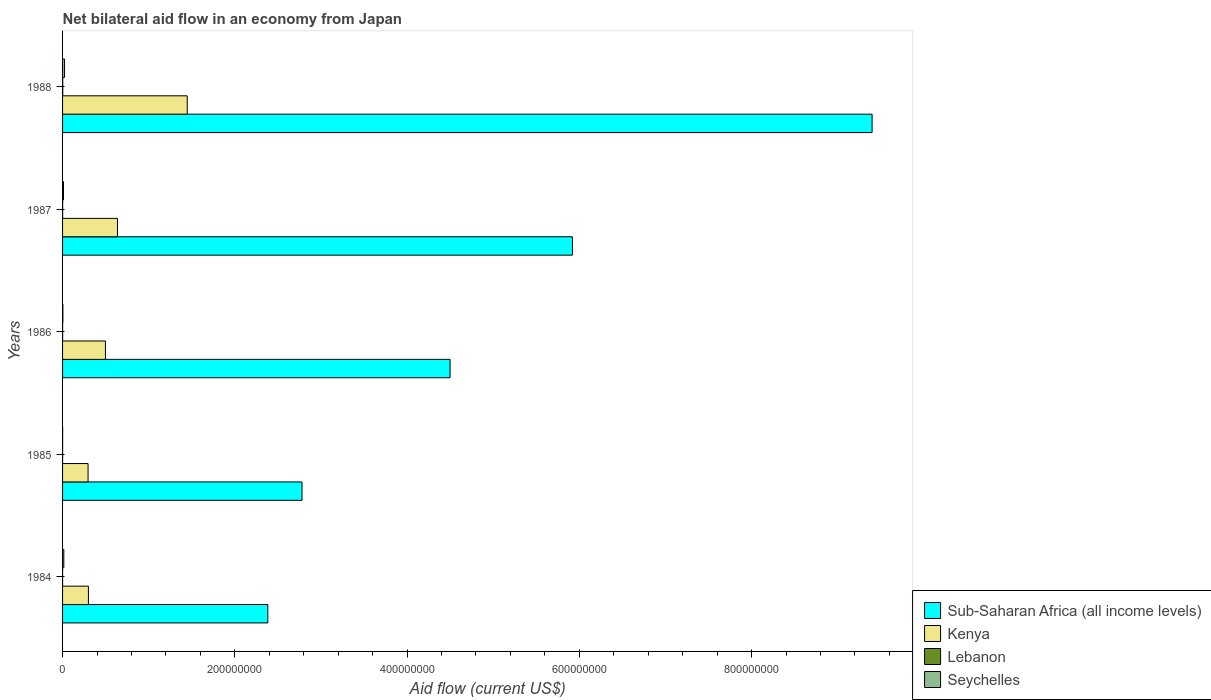How many different coloured bars are there?
Keep it short and to the point. 4. Are the number of bars on each tick of the Y-axis equal?
Your answer should be very brief. Yes. How many bars are there on the 5th tick from the top?
Keep it short and to the point. 4. In how many cases, is the number of bars for a given year not equal to the number of legend labels?
Ensure brevity in your answer.  0. What is the net bilateral aid flow in Lebanon in 1986?
Keep it short and to the point. 5.00e+04. Across all years, what is the maximum net bilateral aid flow in Sub-Saharan Africa (all income levels)?
Give a very brief answer. 9.40e+08. In which year was the net bilateral aid flow in Kenya maximum?
Give a very brief answer. 1988. What is the total net bilateral aid flow in Kenya in the graph?
Make the answer very short. 3.18e+08. What is the difference between the net bilateral aid flow in Kenya in 1986 and that in 1987?
Make the answer very short. -1.40e+07. What is the difference between the net bilateral aid flow in Lebanon in 1988 and the net bilateral aid flow in Seychelles in 1984?
Give a very brief answer. -1.25e+06. What is the average net bilateral aid flow in Sub-Saharan Africa (all income levels) per year?
Give a very brief answer. 5.00e+08. In the year 1985, what is the difference between the net bilateral aid flow in Sub-Saharan Africa (all income levels) and net bilateral aid flow in Seychelles?
Offer a terse response. 2.78e+08. In how many years, is the net bilateral aid flow in Seychelles greater than 120000000 US$?
Your answer should be very brief. 0. What is the ratio of the net bilateral aid flow in Sub-Saharan Africa (all income levels) in 1984 to that in 1986?
Your answer should be compact. 0.53. Is the net bilateral aid flow in Kenya in 1984 less than that in 1986?
Make the answer very short. Yes. Is the difference between the net bilateral aid flow in Sub-Saharan Africa (all income levels) in 1984 and 1987 greater than the difference between the net bilateral aid flow in Seychelles in 1984 and 1987?
Give a very brief answer. No. What is the difference between the highest and the second highest net bilateral aid flow in Seychelles?
Give a very brief answer. 8.60e+05. What is the difference between the highest and the lowest net bilateral aid flow in Sub-Saharan Africa (all income levels)?
Your response must be concise. 7.02e+08. What does the 4th bar from the top in 1987 represents?
Offer a very short reply. Sub-Saharan Africa (all income levels). What does the 3rd bar from the bottom in 1986 represents?
Make the answer very short. Lebanon. How many bars are there?
Make the answer very short. 20. What is the difference between two consecutive major ticks on the X-axis?
Your response must be concise. 2.00e+08. Are the values on the major ticks of X-axis written in scientific E-notation?
Your response must be concise. No. Where does the legend appear in the graph?
Ensure brevity in your answer.  Bottom right. What is the title of the graph?
Your answer should be very brief. Net bilateral aid flow in an economy from Japan. What is the label or title of the X-axis?
Offer a terse response. Aid flow (current US$). What is the label or title of the Y-axis?
Give a very brief answer. Years. What is the Aid flow (current US$) in Sub-Saharan Africa (all income levels) in 1984?
Your answer should be very brief. 2.38e+08. What is the Aid flow (current US$) of Kenya in 1984?
Keep it short and to the point. 3.00e+07. What is the Aid flow (current US$) in Seychelles in 1984?
Ensure brevity in your answer.  1.44e+06. What is the Aid flow (current US$) in Sub-Saharan Africa (all income levels) in 1985?
Keep it short and to the point. 2.78e+08. What is the Aid flow (current US$) of Kenya in 1985?
Offer a very short reply. 2.96e+07. What is the Aid flow (current US$) in Seychelles in 1985?
Your answer should be very brief. 7.00e+04. What is the Aid flow (current US$) in Sub-Saharan Africa (all income levels) in 1986?
Offer a terse response. 4.50e+08. What is the Aid flow (current US$) of Kenya in 1986?
Offer a very short reply. 4.98e+07. What is the Aid flow (current US$) in Lebanon in 1986?
Offer a very short reply. 5.00e+04. What is the Aid flow (current US$) in Seychelles in 1986?
Your answer should be compact. 3.60e+05. What is the Aid flow (current US$) in Sub-Saharan Africa (all income levels) in 1987?
Give a very brief answer. 5.92e+08. What is the Aid flow (current US$) of Kenya in 1987?
Provide a short and direct response. 6.37e+07. What is the Aid flow (current US$) in Lebanon in 1987?
Give a very brief answer. 8.00e+04. What is the Aid flow (current US$) in Seychelles in 1987?
Provide a succinct answer. 1.09e+06. What is the Aid flow (current US$) of Sub-Saharan Africa (all income levels) in 1988?
Offer a very short reply. 9.40e+08. What is the Aid flow (current US$) of Kenya in 1988?
Your answer should be very brief. 1.45e+08. What is the Aid flow (current US$) in Seychelles in 1988?
Your answer should be very brief. 2.30e+06. Across all years, what is the maximum Aid flow (current US$) of Sub-Saharan Africa (all income levels)?
Your answer should be compact. 9.40e+08. Across all years, what is the maximum Aid flow (current US$) in Kenya?
Your answer should be compact. 1.45e+08. Across all years, what is the maximum Aid flow (current US$) of Lebanon?
Provide a short and direct response. 1.90e+05. Across all years, what is the maximum Aid flow (current US$) of Seychelles?
Your answer should be very brief. 2.30e+06. Across all years, what is the minimum Aid flow (current US$) in Sub-Saharan Africa (all income levels)?
Make the answer very short. 2.38e+08. Across all years, what is the minimum Aid flow (current US$) of Kenya?
Your response must be concise. 2.96e+07. Across all years, what is the minimum Aid flow (current US$) of Seychelles?
Make the answer very short. 7.00e+04. What is the total Aid flow (current US$) in Sub-Saharan Africa (all income levels) in the graph?
Your response must be concise. 2.50e+09. What is the total Aid flow (current US$) of Kenya in the graph?
Keep it short and to the point. 3.18e+08. What is the total Aid flow (current US$) in Seychelles in the graph?
Your answer should be compact. 5.26e+06. What is the difference between the Aid flow (current US$) of Sub-Saharan Africa (all income levels) in 1984 and that in 1985?
Provide a succinct answer. -3.97e+07. What is the difference between the Aid flow (current US$) of Kenya in 1984 and that in 1985?
Provide a short and direct response. 4.10e+05. What is the difference between the Aid flow (current US$) in Seychelles in 1984 and that in 1985?
Make the answer very short. 1.37e+06. What is the difference between the Aid flow (current US$) of Sub-Saharan Africa (all income levels) in 1984 and that in 1986?
Give a very brief answer. -2.12e+08. What is the difference between the Aid flow (current US$) of Kenya in 1984 and that in 1986?
Your answer should be compact. -1.98e+07. What is the difference between the Aid flow (current US$) of Seychelles in 1984 and that in 1986?
Your answer should be very brief. 1.08e+06. What is the difference between the Aid flow (current US$) of Sub-Saharan Africa (all income levels) in 1984 and that in 1987?
Offer a terse response. -3.54e+08. What is the difference between the Aid flow (current US$) of Kenya in 1984 and that in 1987?
Offer a very short reply. -3.37e+07. What is the difference between the Aid flow (current US$) of Seychelles in 1984 and that in 1987?
Keep it short and to the point. 3.50e+05. What is the difference between the Aid flow (current US$) in Sub-Saharan Africa (all income levels) in 1984 and that in 1988?
Your response must be concise. -7.02e+08. What is the difference between the Aid flow (current US$) in Kenya in 1984 and that in 1988?
Your response must be concise. -1.15e+08. What is the difference between the Aid flow (current US$) in Seychelles in 1984 and that in 1988?
Ensure brevity in your answer.  -8.60e+05. What is the difference between the Aid flow (current US$) of Sub-Saharan Africa (all income levels) in 1985 and that in 1986?
Keep it short and to the point. -1.72e+08. What is the difference between the Aid flow (current US$) in Kenya in 1985 and that in 1986?
Offer a very short reply. -2.02e+07. What is the difference between the Aid flow (current US$) of Sub-Saharan Africa (all income levels) in 1985 and that in 1987?
Your answer should be compact. -3.14e+08. What is the difference between the Aid flow (current US$) in Kenya in 1985 and that in 1987?
Your answer should be compact. -3.41e+07. What is the difference between the Aid flow (current US$) of Lebanon in 1985 and that in 1987?
Provide a short and direct response. -4.00e+04. What is the difference between the Aid flow (current US$) in Seychelles in 1985 and that in 1987?
Offer a very short reply. -1.02e+06. What is the difference between the Aid flow (current US$) in Sub-Saharan Africa (all income levels) in 1985 and that in 1988?
Provide a short and direct response. -6.62e+08. What is the difference between the Aid flow (current US$) of Kenya in 1985 and that in 1988?
Your answer should be very brief. -1.15e+08. What is the difference between the Aid flow (current US$) in Lebanon in 1985 and that in 1988?
Provide a succinct answer. -1.50e+05. What is the difference between the Aid flow (current US$) in Seychelles in 1985 and that in 1988?
Provide a succinct answer. -2.23e+06. What is the difference between the Aid flow (current US$) in Sub-Saharan Africa (all income levels) in 1986 and that in 1987?
Provide a succinct answer. -1.42e+08. What is the difference between the Aid flow (current US$) in Kenya in 1986 and that in 1987?
Offer a very short reply. -1.40e+07. What is the difference between the Aid flow (current US$) in Seychelles in 1986 and that in 1987?
Offer a very short reply. -7.30e+05. What is the difference between the Aid flow (current US$) in Sub-Saharan Africa (all income levels) in 1986 and that in 1988?
Your answer should be very brief. -4.90e+08. What is the difference between the Aid flow (current US$) of Kenya in 1986 and that in 1988?
Provide a succinct answer. -9.50e+07. What is the difference between the Aid flow (current US$) of Seychelles in 1986 and that in 1988?
Offer a terse response. -1.94e+06. What is the difference between the Aid flow (current US$) of Sub-Saharan Africa (all income levels) in 1987 and that in 1988?
Your answer should be very brief. -3.48e+08. What is the difference between the Aid flow (current US$) in Kenya in 1987 and that in 1988?
Keep it short and to the point. -8.10e+07. What is the difference between the Aid flow (current US$) of Lebanon in 1987 and that in 1988?
Offer a very short reply. -1.10e+05. What is the difference between the Aid flow (current US$) of Seychelles in 1987 and that in 1988?
Provide a succinct answer. -1.21e+06. What is the difference between the Aid flow (current US$) in Sub-Saharan Africa (all income levels) in 1984 and the Aid flow (current US$) in Kenya in 1985?
Provide a short and direct response. 2.09e+08. What is the difference between the Aid flow (current US$) of Sub-Saharan Africa (all income levels) in 1984 and the Aid flow (current US$) of Lebanon in 1985?
Give a very brief answer. 2.38e+08. What is the difference between the Aid flow (current US$) in Sub-Saharan Africa (all income levels) in 1984 and the Aid flow (current US$) in Seychelles in 1985?
Keep it short and to the point. 2.38e+08. What is the difference between the Aid flow (current US$) of Kenya in 1984 and the Aid flow (current US$) of Lebanon in 1985?
Offer a terse response. 3.00e+07. What is the difference between the Aid flow (current US$) in Kenya in 1984 and the Aid flow (current US$) in Seychelles in 1985?
Offer a very short reply. 3.00e+07. What is the difference between the Aid flow (current US$) of Sub-Saharan Africa (all income levels) in 1984 and the Aid flow (current US$) of Kenya in 1986?
Make the answer very short. 1.89e+08. What is the difference between the Aid flow (current US$) of Sub-Saharan Africa (all income levels) in 1984 and the Aid flow (current US$) of Lebanon in 1986?
Offer a very short reply. 2.38e+08. What is the difference between the Aid flow (current US$) in Sub-Saharan Africa (all income levels) in 1984 and the Aid flow (current US$) in Seychelles in 1986?
Provide a succinct answer. 2.38e+08. What is the difference between the Aid flow (current US$) of Kenya in 1984 and the Aid flow (current US$) of Lebanon in 1986?
Provide a succinct answer. 3.00e+07. What is the difference between the Aid flow (current US$) in Kenya in 1984 and the Aid flow (current US$) in Seychelles in 1986?
Ensure brevity in your answer.  2.97e+07. What is the difference between the Aid flow (current US$) of Sub-Saharan Africa (all income levels) in 1984 and the Aid flow (current US$) of Kenya in 1987?
Provide a succinct answer. 1.75e+08. What is the difference between the Aid flow (current US$) in Sub-Saharan Africa (all income levels) in 1984 and the Aid flow (current US$) in Lebanon in 1987?
Give a very brief answer. 2.38e+08. What is the difference between the Aid flow (current US$) in Sub-Saharan Africa (all income levels) in 1984 and the Aid flow (current US$) in Seychelles in 1987?
Provide a short and direct response. 2.37e+08. What is the difference between the Aid flow (current US$) of Kenya in 1984 and the Aid flow (current US$) of Lebanon in 1987?
Make the answer very short. 2.99e+07. What is the difference between the Aid flow (current US$) in Kenya in 1984 and the Aid flow (current US$) in Seychelles in 1987?
Keep it short and to the point. 2.89e+07. What is the difference between the Aid flow (current US$) of Lebanon in 1984 and the Aid flow (current US$) of Seychelles in 1987?
Provide a short and direct response. -1.07e+06. What is the difference between the Aid flow (current US$) in Sub-Saharan Africa (all income levels) in 1984 and the Aid flow (current US$) in Kenya in 1988?
Provide a succinct answer. 9.36e+07. What is the difference between the Aid flow (current US$) of Sub-Saharan Africa (all income levels) in 1984 and the Aid flow (current US$) of Lebanon in 1988?
Make the answer very short. 2.38e+08. What is the difference between the Aid flow (current US$) in Sub-Saharan Africa (all income levels) in 1984 and the Aid flow (current US$) in Seychelles in 1988?
Provide a succinct answer. 2.36e+08. What is the difference between the Aid flow (current US$) in Kenya in 1984 and the Aid flow (current US$) in Lebanon in 1988?
Your response must be concise. 2.98e+07. What is the difference between the Aid flow (current US$) of Kenya in 1984 and the Aid flow (current US$) of Seychelles in 1988?
Offer a very short reply. 2.77e+07. What is the difference between the Aid flow (current US$) of Lebanon in 1984 and the Aid flow (current US$) of Seychelles in 1988?
Give a very brief answer. -2.28e+06. What is the difference between the Aid flow (current US$) of Sub-Saharan Africa (all income levels) in 1985 and the Aid flow (current US$) of Kenya in 1986?
Provide a short and direct response. 2.28e+08. What is the difference between the Aid flow (current US$) of Sub-Saharan Africa (all income levels) in 1985 and the Aid flow (current US$) of Lebanon in 1986?
Your answer should be compact. 2.78e+08. What is the difference between the Aid flow (current US$) of Sub-Saharan Africa (all income levels) in 1985 and the Aid flow (current US$) of Seychelles in 1986?
Your answer should be very brief. 2.78e+08. What is the difference between the Aid flow (current US$) in Kenya in 1985 and the Aid flow (current US$) in Lebanon in 1986?
Keep it short and to the point. 2.96e+07. What is the difference between the Aid flow (current US$) of Kenya in 1985 and the Aid flow (current US$) of Seychelles in 1986?
Offer a terse response. 2.92e+07. What is the difference between the Aid flow (current US$) in Lebanon in 1985 and the Aid flow (current US$) in Seychelles in 1986?
Offer a very short reply. -3.20e+05. What is the difference between the Aid flow (current US$) in Sub-Saharan Africa (all income levels) in 1985 and the Aid flow (current US$) in Kenya in 1987?
Make the answer very short. 2.14e+08. What is the difference between the Aid flow (current US$) of Sub-Saharan Africa (all income levels) in 1985 and the Aid flow (current US$) of Lebanon in 1987?
Keep it short and to the point. 2.78e+08. What is the difference between the Aid flow (current US$) of Sub-Saharan Africa (all income levels) in 1985 and the Aid flow (current US$) of Seychelles in 1987?
Make the answer very short. 2.77e+08. What is the difference between the Aid flow (current US$) of Kenya in 1985 and the Aid flow (current US$) of Lebanon in 1987?
Ensure brevity in your answer.  2.95e+07. What is the difference between the Aid flow (current US$) in Kenya in 1985 and the Aid flow (current US$) in Seychelles in 1987?
Provide a succinct answer. 2.85e+07. What is the difference between the Aid flow (current US$) of Lebanon in 1985 and the Aid flow (current US$) of Seychelles in 1987?
Provide a short and direct response. -1.05e+06. What is the difference between the Aid flow (current US$) in Sub-Saharan Africa (all income levels) in 1985 and the Aid flow (current US$) in Kenya in 1988?
Make the answer very short. 1.33e+08. What is the difference between the Aid flow (current US$) in Sub-Saharan Africa (all income levels) in 1985 and the Aid flow (current US$) in Lebanon in 1988?
Your answer should be compact. 2.78e+08. What is the difference between the Aid flow (current US$) of Sub-Saharan Africa (all income levels) in 1985 and the Aid flow (current US$) of Seychelles in 1988?
Give a very brief answer. 2.76e+08. What is the difference between the Aid flow (current US$) in Kenya in 1985 and the Aid flow (current US$) in Lebanon in 1988?
Offer a very short reply. 2.94e+07. What is the difference between the Aid flow (current US$) in Kenya in 1985 and the Aid flow (current US$) in Seychelles in 1988?
Offer a terse response. 2.73e+07. What is the difference between the Aid flow (current US$) of Lebanon in 1985 and the Aid flow (current US$) of Seychelles in 1988?
Keep it short and to the point. -2.26e+06. What is the difference between the Aid flow (current US$) of Sub-Saharan Africa (all income levels) in 1986 and the Aid flow (current US$) of Kenya in 1987?
Offer a very short reply. 3.86e+08. What is the difference between the Aid flow (current US$) in Sub-Saharan Africa (all income levels) in 1986 and the Aid flow (current US$) in Lebanon in 1987?
Keep it short and to the point. 4.50e+08. What is the difference between the Aid flow (current US$) in Sub-Saharan Africa (all income levels) in 1986 and the Aid flow (current US$) in Seychelles in 1987?
Ensure brevity in your answer.  4.49e+08. What is the difference between the Aid flow (current US$) of Kenya in 1986 and the Aid flow (current US$) of Lebanon in 1987?
Offer a terse response. 4.97e+07. What is the difference between the Aid flow (current US$) in Kenya in 1986 and the Aid flow (current US$) in Seychelles in 1987?
Your answer should be compact. 4.87e+07. What is the difference between the Aid flow (current US$) of Lebanon in 1986 and the Aid flow (current US$) of Seychelles in 1987?
Ensure brevity in your answer.  -1.04e+06. What is the difference between the Aid flow (current US$) in Sub-Saharan Africa (all income levels) in 1986 and the Aid flow (current US$) in Kenya in 1988?
Your response must be concise. 3.05e+08. What is the difference between the Aid flow (current US$) in Sub-Saharan Africa (all income levels) in 1986 and the Aid flow (current US$) in Lebanon in 1988?
Ensure brevity in your answer.  4.50e+08. What is the difference between the Aid flow (current US$) of Sub-Saharan Africa (all income levels) in 1986 and the Aid flow (current US$) of Seychelles in 1988?
Provide a short and direct response. 4.48e+08. What is the difference between the Aid flow (current US$) of Kenya in 1986 and the Aid flow (current US$) of Lebanon in 1988?
Give a very brief answer. 4.96e+07. What is the difference between the Aid flow (current US$) in Kenya in 1986 and the Aid flow (current US$) in Seychelles in 1988?
Your answer should be compact. 4.75e+07. What is the difference between the Aid flow (current US$) in Lebanon in 1986 and the Aid flow (current US$) in Seychelles in 1988?
Offer a terse response. -2.25e+06. What is the difference between the Aid flow (current US$) in Sub-Saharan Africa (all income levels) in 1987 and the Aid flow (current US$) in Kenya in 1988?
Give a very brief answer. 4.47e+08. What is the difference between the Aid flow (current US$) in Sub-Saharan Africa (all income levels) in 1987 and the Aid flow (current US$) in Lebanon in 1988?
Your answer should be compact. 5.92e+08. What is the difference between the Aid flow (current US$) of Sub-Saharan Africa (all income levels) in 1987 and the Aid flow (current US$) of Seychelles in 1988?
Offer a very short reply. 5.90e+08. What is the difference between the Aid flow (current US$) in Kenya in 1987 and the Aid flow (current US$) in Lebanon in 1988?
Give a very brief answer. 6.36e+07. What is the difference between the Aid flow (current US$) of Kenya in 1987 and the Aid flow (current US$) of Seychelles in 1988?
Provide a short and direct response. 6.14e+07. What is the difference between the Aid flow (current US$) in Lebanon in 1987 and the Aid flow (current US$) in Seychelles in 1988?
Offer a very short reply. -2.22e+06. What is the average Aid flow (current US$) in Sub-Saharan Africa (all income levels) per year?
Your answer should be compact. 5.00e+08. What is the average Aid flow (current US$) in Kenya per year?
Keep it short and to the point. 6.36e+07. What is the average Aid flow (current US$) in Lebanon per year?
Your response must be concise. 7.60e+04. What is the average Aid flow (current US$) in Seychelles per year?
Make the answer very short. 1.05e+06. In the year 1984, what is the difference between the Aid flow (current US$) of Sub-Saharan Africa (all income levels) and Aid flow (current US$) of Kenya?
Your answer should be very brief. 2.08e+08. In the year 1984, what is the difference between the Aid flow (current US$) in Sub-Saharan Africa (all income levels) and Aid flow (current US$) in Lebanon?
Your response must be concise. 2.38e+08. In the year 1984, what is the difference between the Aid flow (current US$) of Sub-Saharan Africa (all income levels) and Aid flow (current US$) of Seychelles?
Your response must be concise. 2.37e+08. In the year 1984, what is the difference between the Aid flow (current US$) of Kenya and Aid flow (current US$) of Lebanon?
Your answer should be very brief. 3.00e+07. In the year 1984, what is the difference between the Aid flow (current US$) in Kenya and Aid flow (current US$) in Seychelles?
Offer a very short reply. 2.86e+07. In the year 1984, what is the difference between the Aid flow (current US$) in Lebanon and Aid flow (current US$) in Seychelles?
Offer a terse response. -1.42e+06. In the year 1985, what is the difference between the Aid flow (current US$) of Sub-Saharan Africa (all income levels) and Aid flow (current US$) of Kenya?
Give a very brief answer. 2.48e+08. In the year 1985, what is the difference between the Aid flow (current US$) in Sub-Saharan Africa (all income levels) and Aid flow (current US$) in Lebanon?
Provide a short and direct response. 2.78e+08. In the year 1985, what is the difference between the Aid flow (current US$) of Sub-Saharan Africa (all income levels) and Aid flow (current US$) of Seychelles?
Offer a terse response. 2.78e+08. In the year 1985, what is the difference between the Aid flow (current US$) in Kenya and Aid flow (current US$) in Lebanon?
Ensure brevity in your answer.  2.96e+07. In the year 1985, what is the difference between the Aid flow (current US$) in Kenya and Aid flow (current US$) in Seychelles?
Your answer should be compact. 2.95e+07. In the year 1985, what is the difference between the Aid flow (current US$) in Lebanon and Aid flow (current US$) in Seychelles?
Keep it short and to the point. -3.00e+04. In the year 1986, what is the difference between the Aid flow (current US$) in Sub-Saharan Africa (all income levels) and Aid flow (current US$) in Kenya?
Give a very brief answer. 4.00e+08. In the year 1986, what is the difference between the Aid flow (current US$) of Sub-Saharan Africa (all income levels) and Aid flow (current US$) of Lebanon?
Keep it short and to the point. 4.50e+08. In the year 1986, what is the difference between the Aid flow (current US$) of Sub-Saharan Africa (all income levels) and Aid flow (current US$) of Seychelles?
Your response must be concise. 4.50e+08. In the year 1986, what is the difference between the Aid flow (current US$) in Kenya and Aid flow (current US$) in Lebanon?
Provide a succinct answer. 4.97e+07. In the year 1986, what is the difference between the Aid flow (current US$) in Kenya and Aid flow (current US$) in Seychelles?
Keep it short and to the point. 4.94e+07. In the year 1986, what is the difference between the Aid flow (current US$) in Lebanon and Aid flow (current US$) in Seychelles?
Your answer should be very brief. -3.10e+05. In the year 1987, what is the difference between the Aid flow (current US$) in Sub-Saharan Africa (all income levels) and Aid flow (current US$) in Kenya?
Your answer should be very brief. 5.28e+08. In the year 1987, what is the difference between the Aid flow (current US$) of Sub-Saharan Africa (all income levels) and Aid flow (current US$) of Lebanon?
Give a very brief answer. 5.92e+08. In the year 1987, what is the difference between the Aid flow (current US$) in Sub-Saharan Africa (all income levels) and Aid flow (current US$) in Seychelles?
Your response must be concise. 5.91e+08. In the year 1987, what is the difference between the Aid flow (current US$) of Kenya and Aid flow (current US$) of Lebanon?
Give a very brief answer. 6.37e+07. In the year 1987, what is the difference between the Aid flow (current US$) of Kenya and Aid flow (current US$) of Seychelles?
Your answer should be compact. 6.26e+07. In the year 1987, what is the difference between the Aid flow (current US$) of Lebanon and Aid flow (current US$) of Seychelles?
Give a very brief answer. -1.01e+06. In the year 1988, what is the difference between the Aid flow (current US$) in Sub-Saharan Africa (all income levels) and Aid flow (current US$) in Kenya?
Your answer should be compact. 7.95e+08. In the year 1988, what is the difference between the Aid flow (current US$) of Sub-Saharan Africa (all income levels) and Aid flow (current US$) of Lebanon?
Your answer should be very brief. 9.40e+08. In the year 1988, what is the difference between the Aid flow (current US$) of Sub-Saharan Africa (all income levels) and Aid flow (current US$) of Seychelles?
Your response must be concise. 9.38e+08. In the year 1988, what is the difference between the Aid flow (current US$) of Kenya and Aid flow (current US$) of Lebanon?
Your response must be concise. 1.45e+08. In the year 1988, what is the difference between the Aid flow (current US$) in Kenya and Aid flow (current US$) in Seychelles?
Ensure brevity in your answer.  1.42e+08. In the year 1988, what is the difference between the Aid flow (current US$) in Lebanon and Aid flow (current US$) in Seychelles?
Offer a very short reply. -2.11e+06. What is the ratio of the Aid flow (current US$) of Sub-Saharan Africa (all income levels) in 1984 to that in 1985?
Provide a short and direct response. 0.86. What is the ratio of the Aid flow (current US$) of Kenya in 1984 to that in 1985?
Keep it short and to the point. 1.01. What is the ratio of the Aid flow (current US$) of Lebanon in 1984 to that in 1985?
Provide a short and direct response. 0.5. What is the ratio of the Aid flow (current US$) of Seychelles in 1984 to that in 1985?
Provide a succinct answer. 20.57. What is the ratio of the Aid flow (current US$) in Sub-Saharan Africa (all income levels) in 1984 to that in 1986?
Keep it short and to the point. 0.53. What is the ratio of the Aid flow (current US$) of Kenya in 1984 to that in 1986?
Make the answer very short. 0.6. What is the ratio of the Aid flow (current US$) of Lebanon in 1984 to that in 1986?
Your response must be concise. 0.4. What is the ratio of the Aid flow (current US$) in Sub-Saharan Africa (all income levels) in 1984 to that in 1987?
Your answer should be very brief. 0.4. What is the ratio of the Aid flow (current US$) of Kenya in 1984 to that in 1987?
Ensure brevity in your answer.  0.47. What is the ratio of the Aid flow (current US$) of Seychelles in 1984 to that in 1987?
Your response must be concise. 1.32. What is the ratio of the Aid flow (current US$) of Sub-Saharan Africa (all income levels) in 1984 to that in 1988?
Offer a very short reply. 0.25. What is the ratio of the Aid flow (current US$) of Kenya in 1984 to that in 1988?
Your answer should be very brief. 0.21. What is the ratio of the Aid flow (current US$) of Lebanon in 1984 to that in 1988?
Your response must be concise. 0.11. What is the ratio of the Aid flow (current US$) in Seychelles in 1984 to that in 1988?
Your answer should be very brief. 0.63. What is the ratio of the Aid flow (current US$) in Sub-Saharan Africa (all income levels) in 1985 to that in 1986?
Offer a terse response. 0.62. What is the ratio of the Aid flow (current US$) of Kenya in 1985 to that in 1986?
Provide a succinct answer. 0.59. What is the ratio of the Aid flow (current US$) in Lebanon in 1985 to that in 1986?
Give a very brief answer. 0.8. What is the ratio of the Aid flow (current US$) of Seychelles in 1985 to that in 1986?
Offer a terse response. 0.19. What is the ratio of the Aid flow (current US$) of Sub-Saharan Africa (all income levels) in 1985 to that in 1987?
Ensure brevity in your answer.  0.47. What is the ratio of the Aid flow (current US$) of Kenya in 1985 to that in 1987?
Offer a very short reply. 0.46. What is the ratio of the Aid flow (current US$) in Seychelles in 1985 to that in 1987?
Offer a terse response. 0.06. What is the ratio of the Aid flow (current US$) of Sub-Saharan Africa (all income levels) in 1985 to that in 1988?
Your answer should be compact. 0.3. What is the ratio of the Aid flow (current US$) in Kenya in 1985 to that in 1988?
Offer a very short reply. 0.2. What is the ratio of the Aid flow (current US$) of Lebanon in 1985 to that in 1988?
Make the answer very short. 0.21. What is the ratio of the Aid flow (current US$) of Seychelles in 1985 to that in 1988?
Offer a very short reply. 0.03. What is the ratio of the Aid flow (current US$) in Sub-Saharan Africa (all income levels) in 1986 to that in 1987?
Give a very brief answer. 0.76. What is the ratio of the Aid flow (current US$) of Kenya in 1986 to that in 1987?
Offer a very short reply. 0.78. What is the ratio of the Aid flow (current US$) of Lebanon in 1986 to that in 1987?
Your answer should be compact. 0.62. What is the ratio of the Aid flow (current US$) in Seychelles in 1986 to that in 1987?
Make the answer very short. 0.33. What is the ratio of the Aid flow (current US$) in Sub-Saharan Africa (all income levels) in 1986 to that in 1988?
Offer a very short reply. 0.48. What is the ratio of the Aid flow (current US$) of Kenya in 1986 to that in 1988?
Offer a very short reply. 0.34. What is the ratio of the Aid flow (current US$) in Lebanon in 1986 to that in 1988?
Your answer should be very brief. 0.26. What is the ratio of the Aid flow (current US$) of Seychelles in 1986 to that in 1988?
Your answer should be very brief. 0.16. What is the ratio of the Aid flow (current US$) in Sub-Saharan Africa (all income levels) in 1987 to that in 1988?
Give a very brief answer. 0.63. What is the ratio of the Aid flow (current US$) in Kenya in 1987 to that in 1988?
Keep it short and to the point. 0.44. What is the ratio of the Aid flow (current US$) of Lebanon in 1987 to that in 1988?
Give a very brief answer. 0.42. What is the ratio of the Aid flow (current US$) of Seychelles in 1987 to that in 1988?
Make the answer very short. 0.47. What is the difference between the highest and the second highest Aid flow (current US$) of Sub-Saharan Africa (all income levels)?
Provide a short and direct response. 3.48e+08. What is the difference between the highest and the second highest Aid flow (current US$) of Kenya?
Your answer should be compact. 8.10e+07. What is the difference between the highest and the second highest Aid flow (current US$) of Lebanon?
Ensure brevity in your answer.  1.10e+05. What is the difference between the highest and the second highest Aid flow (current US$) in Seychelles?
Your answer should be very brief. 8.60e+05. What is the difference between the highest and the lowest Aid flow (current US$) of Sub-Saharan Africa (all income levels)?
Provide a succinct answer. 7.02e+08. What is the difference between the highest and the lowest Aid flow (current US$) in Kenya?
Your response must be concise. 1.15e+08. What is the difference between the highest and the lowest Aid flow (current US$) of Seychelles?
Offer a very short reply. 2.23e+06. 